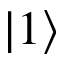<formula> <loc_0><loc_0><loc_500><loc_500>\left | 1 \right \rangle</formula> 